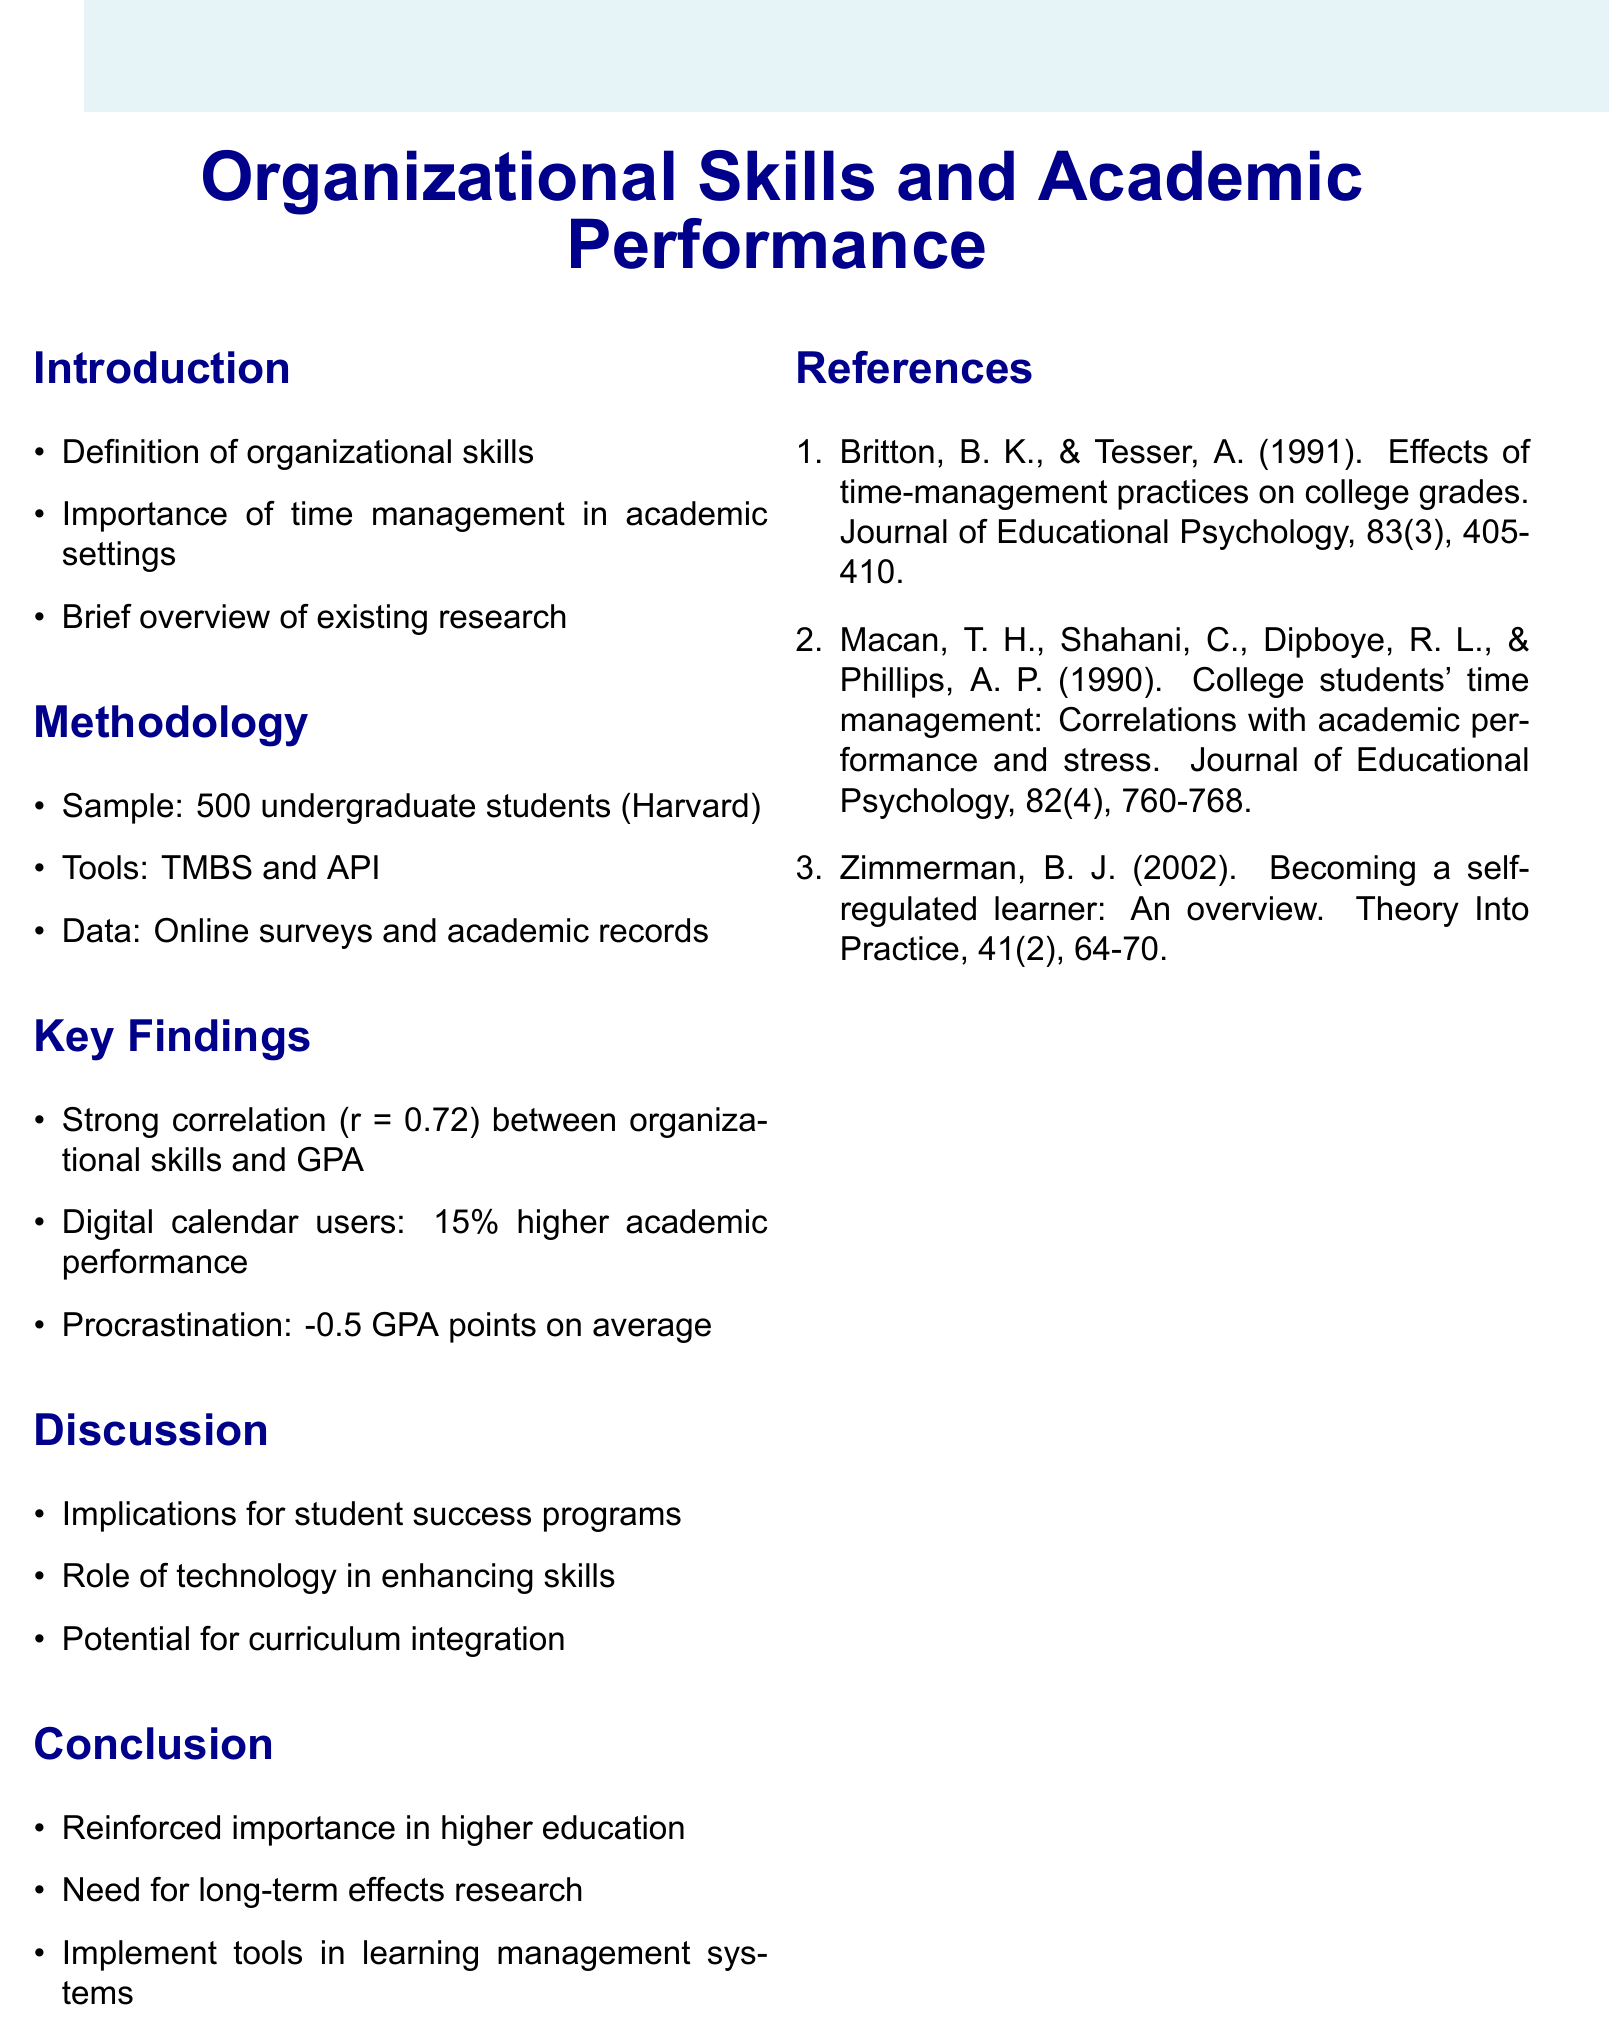What is the title of the research paper? The title is clearly stated at the beginning of the document, summarizing the main focus of the research.
Answer: Organizational Skills and Academic Performance in Higher Education How many undergraduate students were sampled for the study? The methodology section specifies the number of participants involved in the research.
Answer: 500 What tool was used to assess time management behavior? The methodology section lists the tools utilized for data collection and assessment in the study.
Answer: Time Management Behavior Scale (TMBS) What was the correlation coefficient found between organizational skills and GPA? The key findings section provides a specific statistical measure regarding the relationship between the two variables studied.
Answer: 0.72 By how much did digital calendar users outperform their peers academically? The key findings section indicates a quantifiable advantage for students who used digital calendars in their academic performance.
Answer: 15 percent What is one implication discussed in the research for student success programs? The discussion section outlines potential outcomes and applications of the findings, particularly in relation to support programs for students.
Answer: Implications for student success programs What type of training is suggested for integration into the curriculum? The discussion highlights a particular area of development that could benefit students based on the findings of the research.
Answer: Time management training What is recommended for further research in the conclusion? The conclusion reiterates the need for additional study in a specific area related to the research conducted.
Answer: Long-term effects 